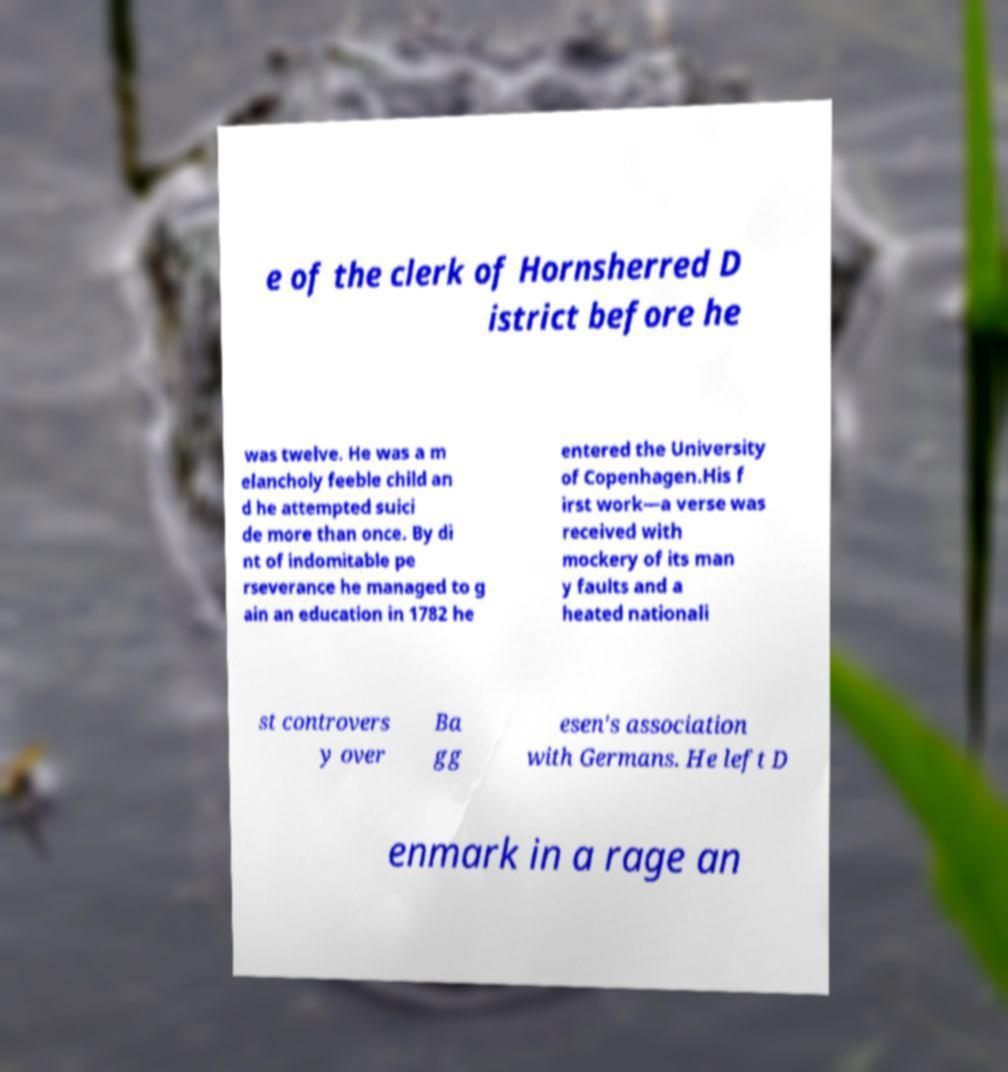I need the written content from this picture converted into text. Can you do that? e of the clerk of Hornsherred D istrict before he was twelve. He was a m elancholy feeble child an d he attempted suici de more than once. By di nt of indomitable pe rseverance he managed to g ain an education in 1782 he entered the University of Copenhagen.His f irst work—a verse was received with mockery of its man y faults and a heated nationali st controvers y over Ba gg esen's association with Germans. He left D enmark in a rage an 